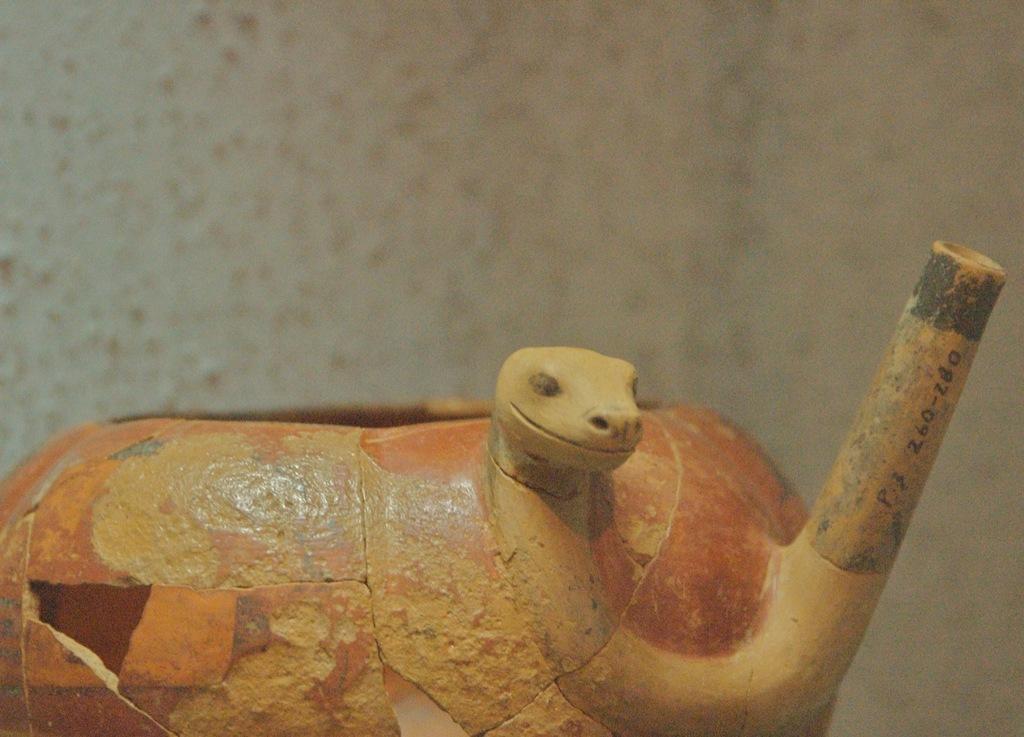Could you give a brief overview of what you see in this image? In this image I can see an object which is in yellow and an orange color. I can see the blurred background. 